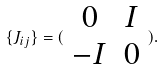<formula> <loc_0><loc_0><loc_500><loc_500>\{ J _ { i j } \} = ( \begin{array} { c c } 0 & I \\ - I & 0 \end{array} ) .</formula> 